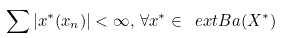Convert formula to latex. <formula><loc_0><loc_0><loc_500><loc_500>\sum | x ^ { * } ( x _ { n } ) | < \infty , \, \forall x ^ { * } \in \ e x t B a ( X ^ { * } )</formula> 